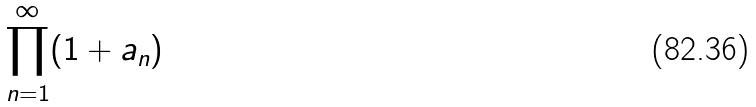Convert formula to latex. <formula><loc_0><loc_0><loc_500><loc_500>\prod _ { n = 1 } ^ { \infty } ( 1 + a _ { n } )</formula> 